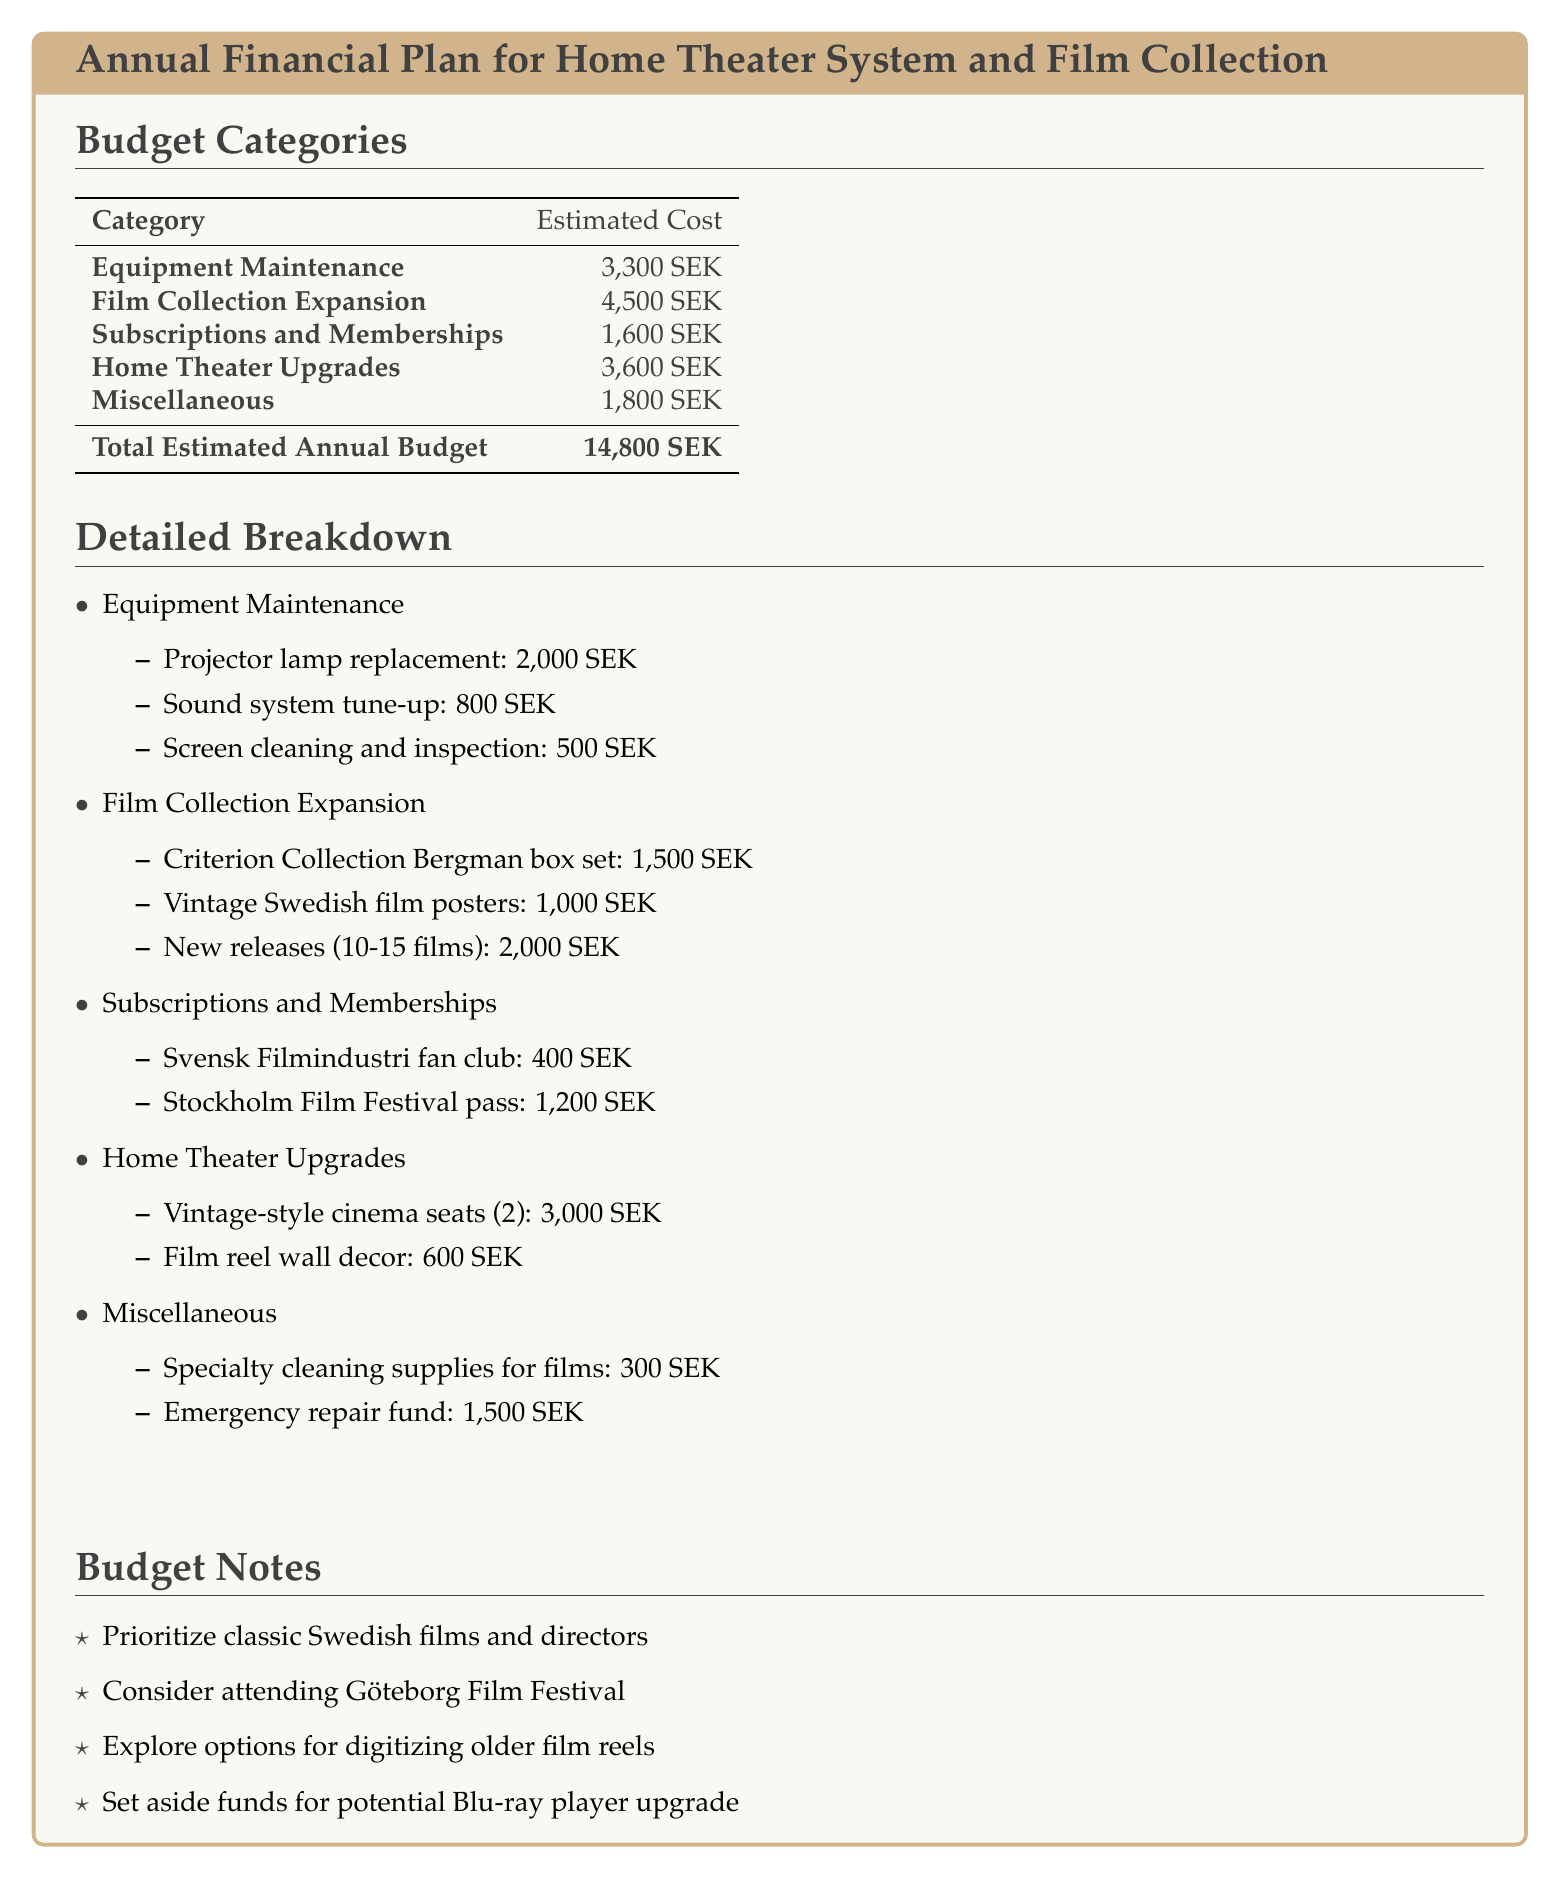What is the total estimated annual budget? The total estimated annual budget is found in the bottom row of the table summarizing all costs.
Answer: 14,800 SEK How much is allocated for the Criterion Collection Bergman box set? The specific cost for this item is listed under the Film Collection Expansion category.
Answer: 1,500 SEK What is the cost for upgrading the vintage-style cinema seats? The cost for the cinema seats is included in the Home Theater Upgrades section of the budget.
Answer: 3,000 SEK What is the estimated cost for subscriptions and memberships in total? The total cost for subscriptions and memberships can be found by adding the items in that section together.
Answer: 1,600 SEK How much is set aside for the emergency repair fund? The emergency repair fund amount is mentioned under the Miscellaneous category.
Answer: 1,500 SEK What category has the highest estimated cost? The category with the highest cost can be identified by comparing all the budget categories.
Answer: Film Collection Expansion Which film festival is mentioned in the budget notes? The specific film festival referenced can be found in the notes section of the document.
Answer: Göteborg Film Festival What is the budget allocated for specialty cleaning supplies for films? This amount appears in the Miscellaneous section under specific expenses.
Answer: 300 SEK What is suggested for upgrading the home theater in the notes? The suggestion for upgrading is mentioned as a potential expense in the notes section of the document.
Answer: Blu-ray player upgrade 